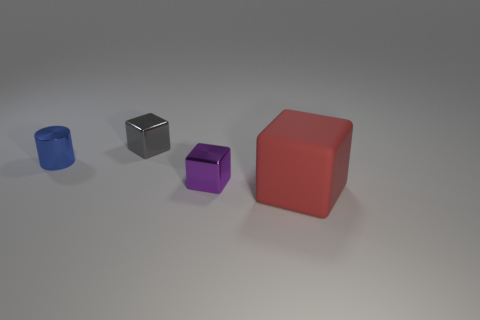Add 3 small red metallic cylinders. How many objects exist? 7 Subtract all cylinders. How many objects are left? 3 Add 1 tiny blue metallic cylinders. How many tiny blue metallic cylinders exist? 2 Subtract 0 gray cylinders. How many objects are left? 4 Subtract all large red things. Subtract all metallic cubes. How many objects are left? 1 Add 3 tiny cubes. How many tiny cubes are left? 5 